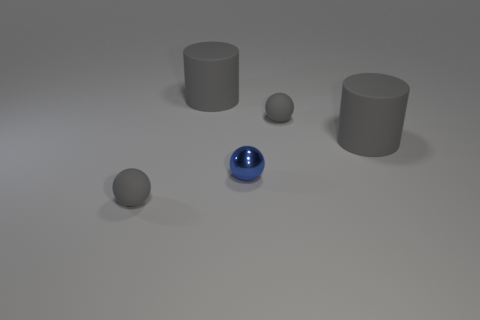Subtract all gray rubber balls. How many balls are left? 1 Subtract all gray cylinders. How many gray balls are left? 2 Subtract 1 spheres. How many spheres are left? 2 Add 1 tiny gray rubber spheres. How many objects exist? 6 Subtract all brown spheres. Subtract all gray blocks. How many spheres are left? 3 Subtract all cylinders. How many objects are left? 3 Add 2 gray objects. How many gray objects are left? 6 Add 4 gray matte cylinders. How many gray matte cylinders exist? 6 Subtract 1 blue spheres. How many objects are left? 4 Subtract all large objects. Subtract all small shiny things. How many objects are left? 2 